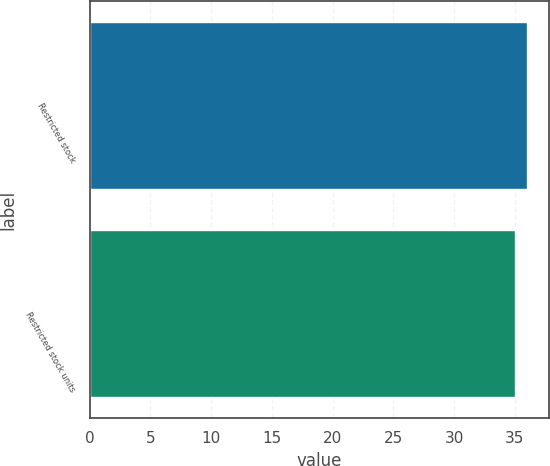Convert chart. <chart><loc_0><loc_0><loc_500><loc_500><bar_chart><fcel>Restricted stock<fcel>Restricted stock units<nl><fcel>36<fcel>35<nl></chart> 